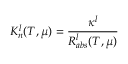<formula> <loc_0><loc_0><loc_500><loc_500>{ K _ { n } ^ { l } ( T , \mu ) = \frac { \kappa ^ { l } } { R _ { a b s } ^ { l } ( T , \mu ) } }</formula> 